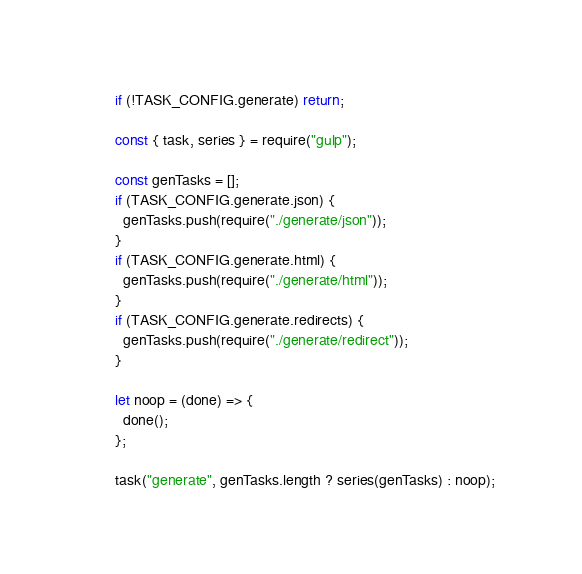Convert code to text. <code><loc_0><loc_0><loc_500><loc_500><_JavaScript_>if (!TASK_CONFIG.generate) return;

const { task, series } = require("gulp");

const genTasks = [];
if (TASK_CONFIG.generate.json) {
  genTasks.push(require("./generate/json"));
}
if (TASK_CONFIG.generate.html) {
  genTasks.push(require("./generate/html"));
}
if (TASK_CONFIG.generate.redirects) {
  genTasks.push(require("./generate/redirect"));
}

let noop = (done) => {
  done();
};

task("generate", genTasks.length ? series(genTasks) : noop);
</code> 